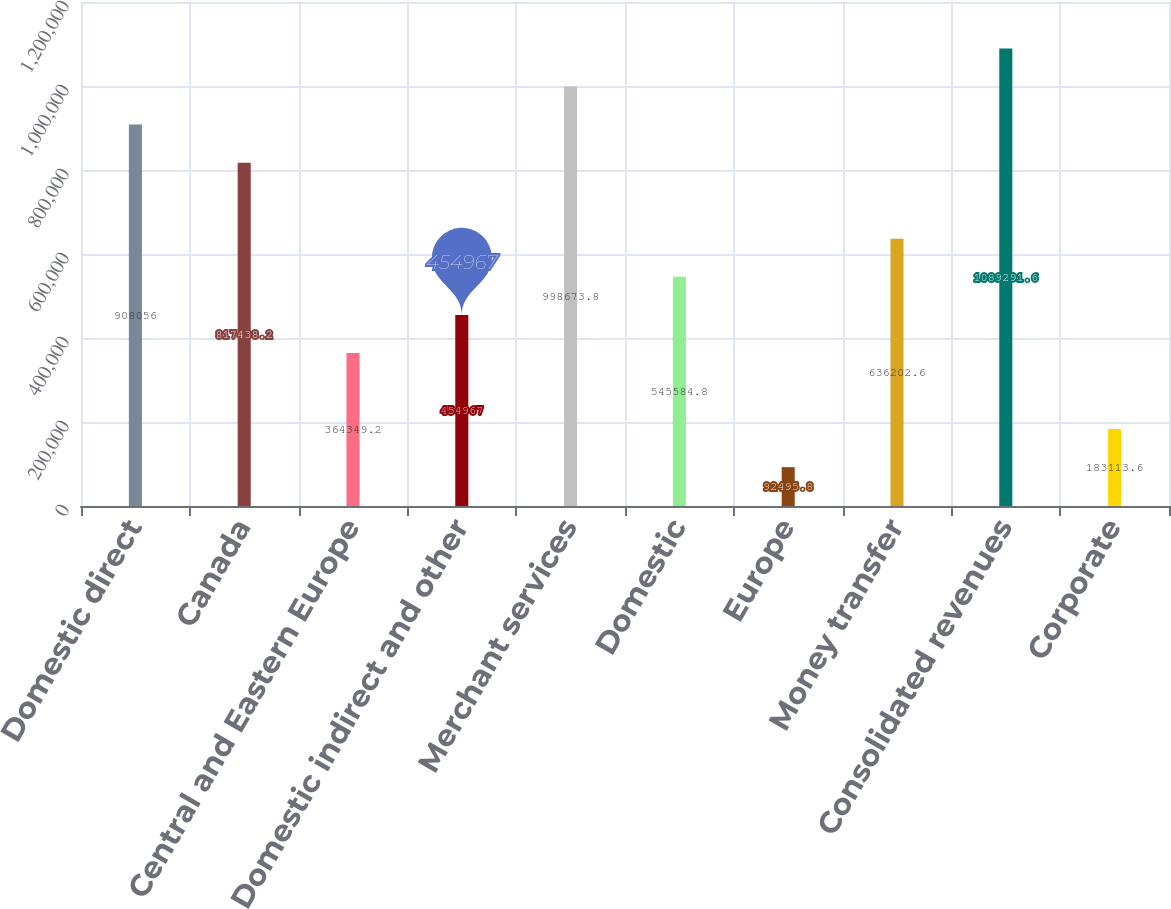<chart> <loc_0><loc_0><loc_500><loc_500><bar_chart><fcel>Domestic direct<fcel>Canada<fcel>Central and Eastern Europe<fcel>Domestic indirect and other<fcel>Merchant services<fcel>Domestic<fcel>Europe<fcel>Money transfer<fcel>Consolidated revenues<fcel>Corporate<nl><fcel>908056<fcel>817438<fcel>364349<fcel>454967<fcel>998674<fcel>545585<fcel>92495.8<fcel>636203<fcel>1.08929e+06<fcel>183114<nl></chart> 